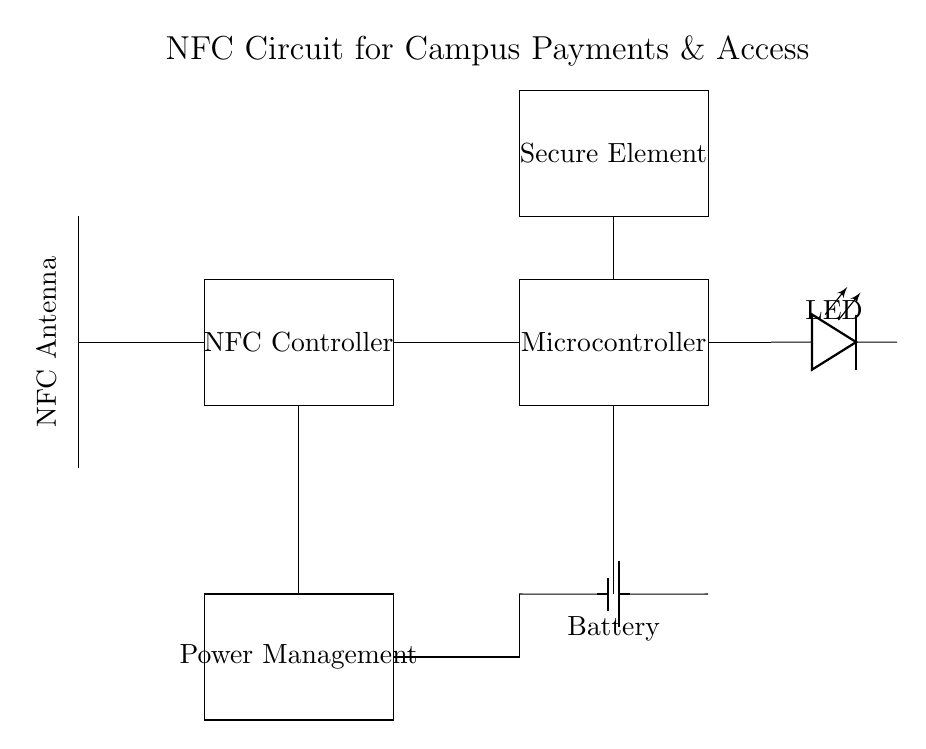What component is connected to the NFC antenna? The NFC antenna is connected to the NFC controller which receives signals from the antenna for processing.
Answer: NFC controller What does the LED indicate in this circuit? The LED is an indicator light that likely shows the status of the NFC circuit, such as power on, processing, or successful transactions.
Answer: Status How many main components are visible in the circuit? The circuit contains five main components: NFC antenna, NFC controller, microcontroller, power management, and secure element.
Answer: Five What is the purpose of the microcontroller in this NFC circuit? The microcontroller processes data received from the NFC controller and handles communication with the secure element, managing tasks like transaction validation and access control.
Answer: Data processing Which component is responsible for power management? The power management component is responsible for regulating power distribution from the battery to the various parts of the circuit, ensuring optimal performance and safety.
Answer: Power management What connects the NFC controller to the microcontroller? The connection between the NFC controller and the microcontroller is a direct line indicating data transfer or communication, essential for processing the NFC signals received.
Answer: Direct line Where is the battery located in the circuit? The battery is located on the right-hand side of the circuit, supplying power to the microcontroller and other components in the circuit.
Answer: Right-hand side 